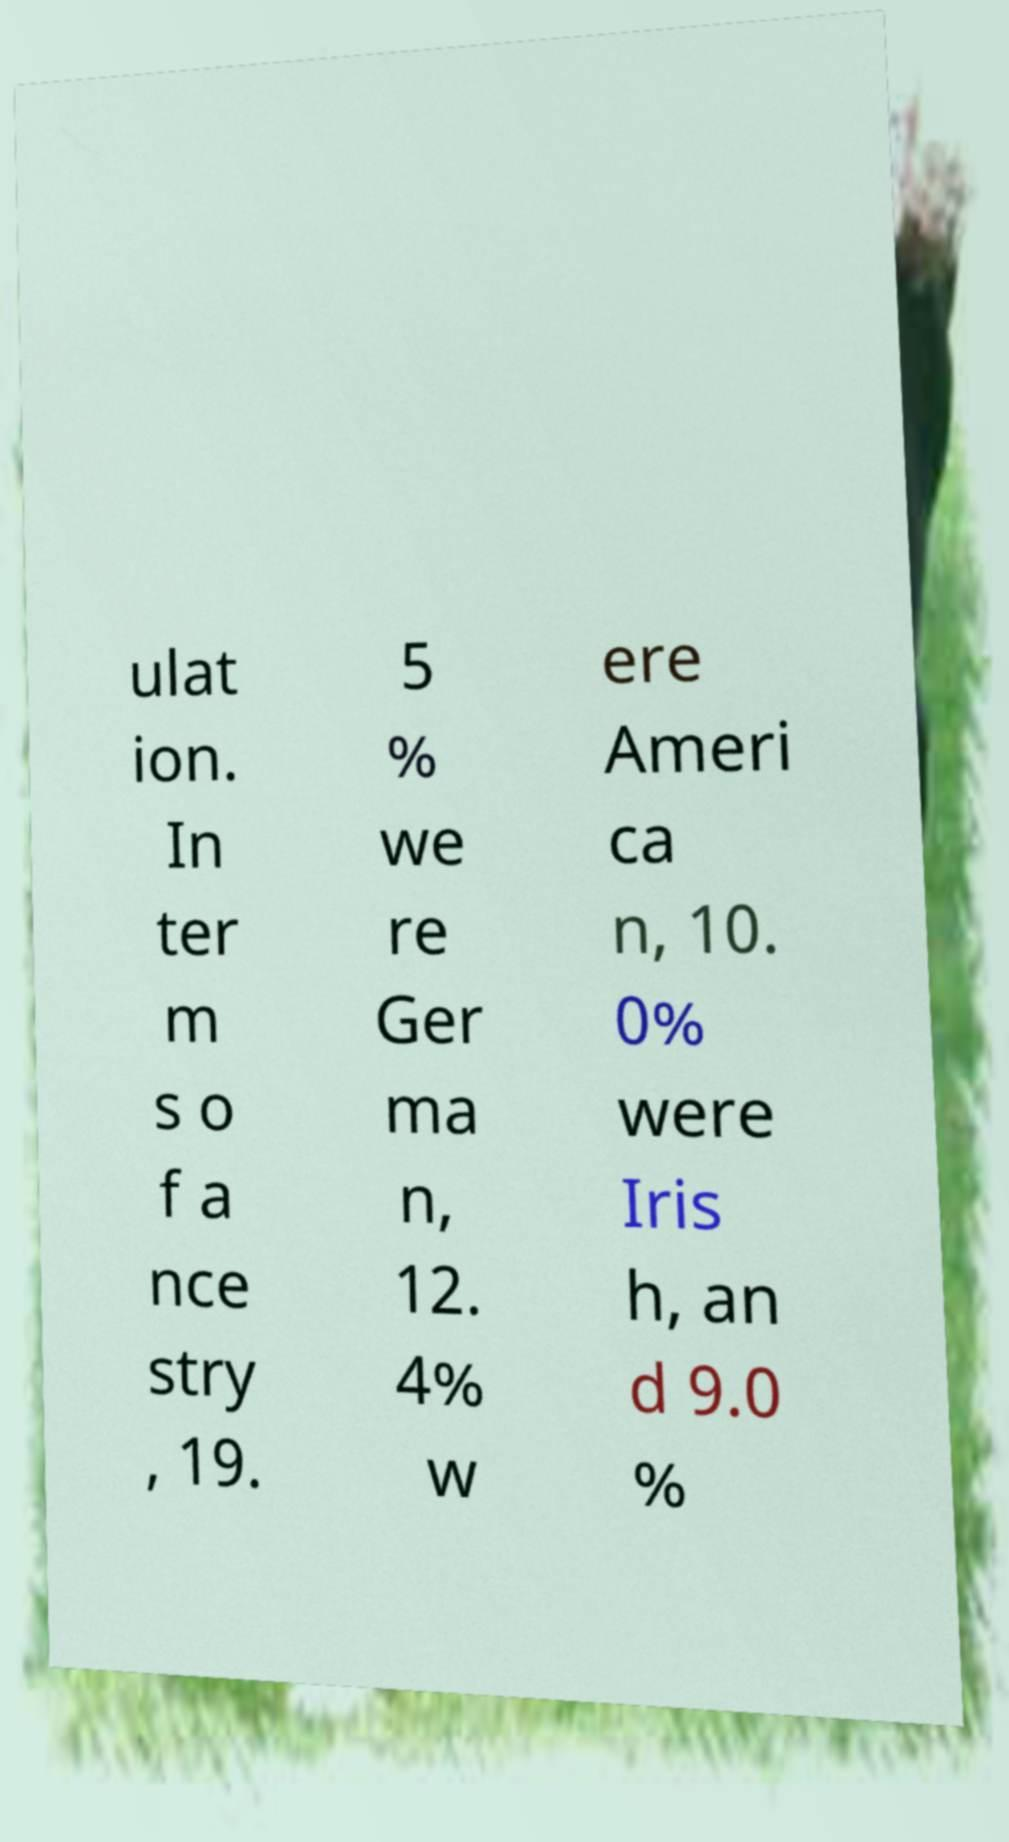For documentation purposes, I need the text within this image transcribed. Could you provide that? ulat ion. In ter m s o f a nce stry , 19. 5 % we re Ger ma n, 12. 4% w ere Ameri ca n, 10. 0% were Iris h, an d 9.0 % 